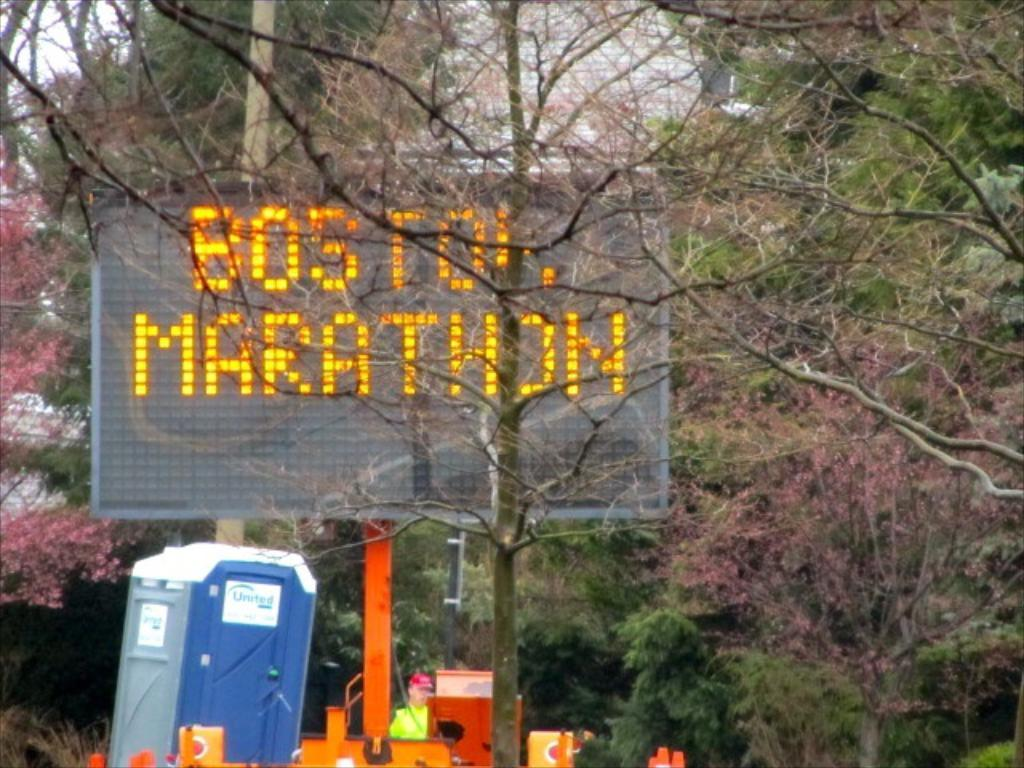What is the main object in the image? There is a digital ad board in the image. Can you describe the person in the image? A person is standing behind the ad board. What is located on the left side of the image? There is a bathroom on the left side of the image. What type of natural elements can be seen in the image? Trees are visible in the image, covering various areas. What type of iron is being used to care for the trees in the image? There is no iron present in the image, nor is there any indication of tree care being performed. 